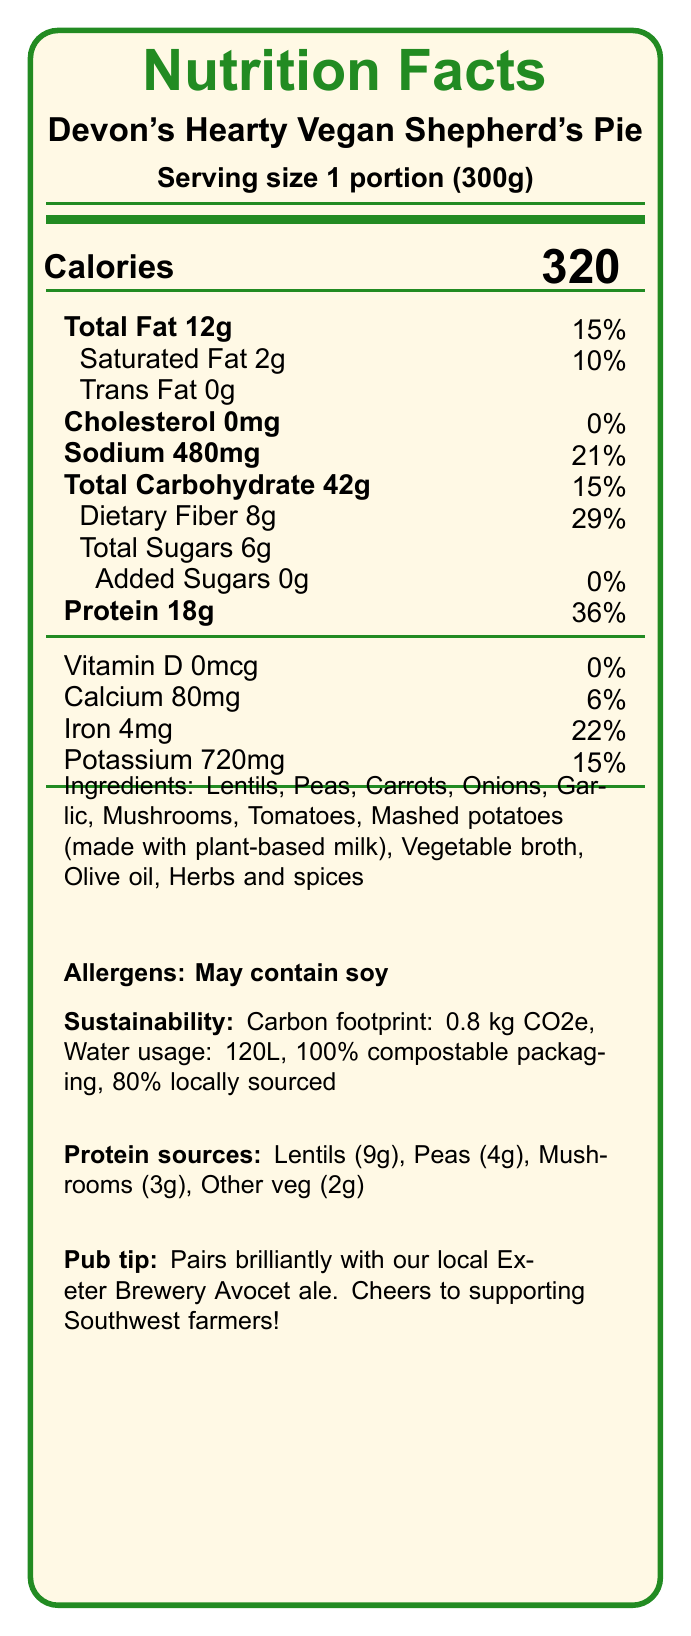what is the serving size of Devon's Hearty Vegan Shepherd's Pie? The serving size is explicitly mentioned as "1 portion (300g)" in the document.
Answer: 1 portion (300g) how many grams of protein are there per serving? The nutrition label states that there are 18 grams of protein per serving.
Answer: 18g which ingredient provides the highest amount of protein? The document lists the protein sources and indicates that lentils provide 9g of protein, which is the highest among the mentioned ingredients.
Answer: Lentils does the product contain any added sugars? The added sugars section of the nutrition label shows "0g" and 0%, indicating there are no added sugars.
Answer: No how much sodium is in one serving? The sodium content is specified as 480mg, which is 21% of the daily value.
Answer: 480mg what is the carbon footprint per serving? The sustainability information mentions that the carbon footprint is 0.8 kg CO2e per serving.
Answer: 0.8 kg CO2e which of the following is the best pair for Devon's Hearty Vegan Shepherd's Pie according to the pub? i. A cup of tea ii. A glass of milk iii. Exeter Brewery Avocet ale iv. A can of soda The pub-specific info recommends pairing it with the local Exeter Brewery Avocet ale.
Answer: iii. Exeter Brewery Avocet ale what percentage of the ingredients are sourced from local farms in Devon and Cornwall?
A. 50%
B. 60%
C. 80%
D. 100% The sustainability information indicates that 80% of the ingredients are sourced from Devon and Cornwall farms.
Answer: C. 80% does the product contain any cholesterol? The nutrition label lists cholesterol as "0mg" and 0%, indicating no cholesterol content.
Answer: No is this product suitable for someone who is allergic to soy? The allergens section mentions that it "May contain soy," so it might not be suitable for someone with a soy allergy.
Answer: No describe the main idea of the document. The document gives detailed information about the nutritional values, ingredients, and sustainability efforts for the vegan product, highlighting local sourcing and its high protein content.
Answer: This document is a nutrition facts label for Devon's Hearty Vegan Shepherd's Pie, outlining its nutritional content, ingredients, sustainability features, and local sourcing. It emphasizes the high protein content and provides pairing suggestions. what is the total carbohydrate content per serving? The total carbohydrate content is indicated as 42g, which is 15% of the daily value.
Answer: 42g how much iron is present per serving? The nutrition label shows that one serving contains 4mg of iron, which is 22% of the daily value.
Answer: 4mg list three main protein sources in the dish. A. Lentils, Peas, Mushrooms B. Carrots, Olive oil, Tomatoes C. Onions, Garlic, Vegetable broth The document lists lentils, peas, and mushrooms as primary protein sources.
Answer: A. Lentils, Peas, Mushrooms what is the water usage per serving? The sustainability information lists the water usage per serving as 120 liters.
Answer: 120 liters how was the recipe adapted in response to Brexit? The pub-specific information mentions that the recipe was adapted to use British-grown pulses due to Brexit impacts.
Answer: The recipe adapted to use British-grown pulses instead of imported soy products are there any trans fats in this dish? The nutrition label indicates "Trans Fat 0g," confirming there are no trans fats in the dish.
Answer: No what type of packaging is used for this product? The sustainability section mentions that the packaging is 100% compostable.
Answer: 100% compostable container what is your estimate of the total cost to produce this dish? The document does not provide any information about the cost to produce the dish.
Answer: Not enough information 